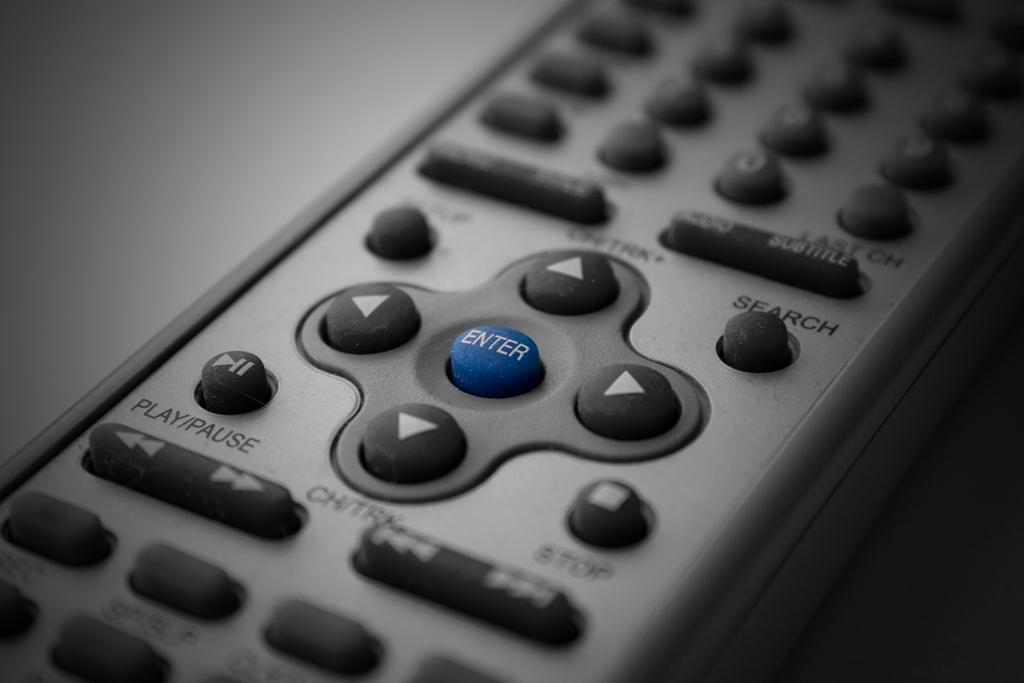<image>
Write a terse but informative summary of the picture. A remote device close up, focusing on the blue enter button. 